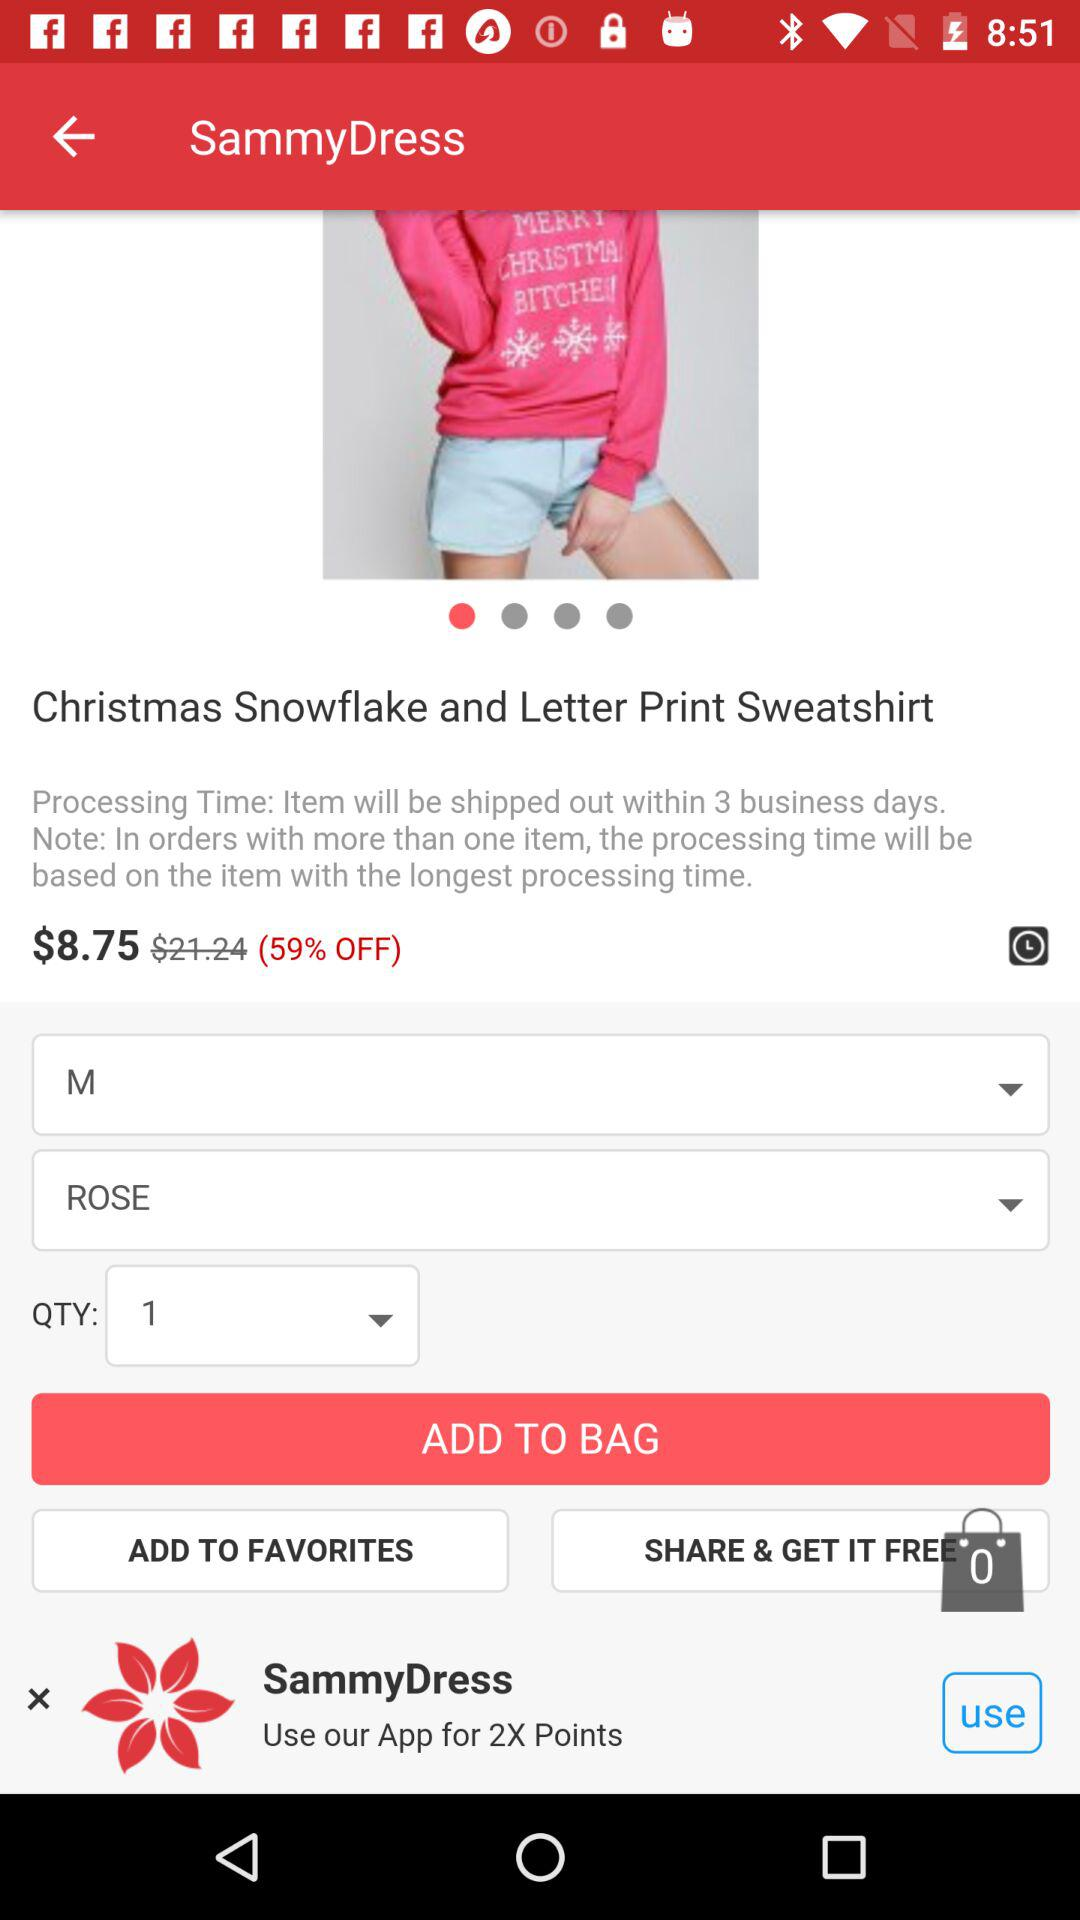What is the color of the sweatshirt? The color of the sweatshirt is rose. 